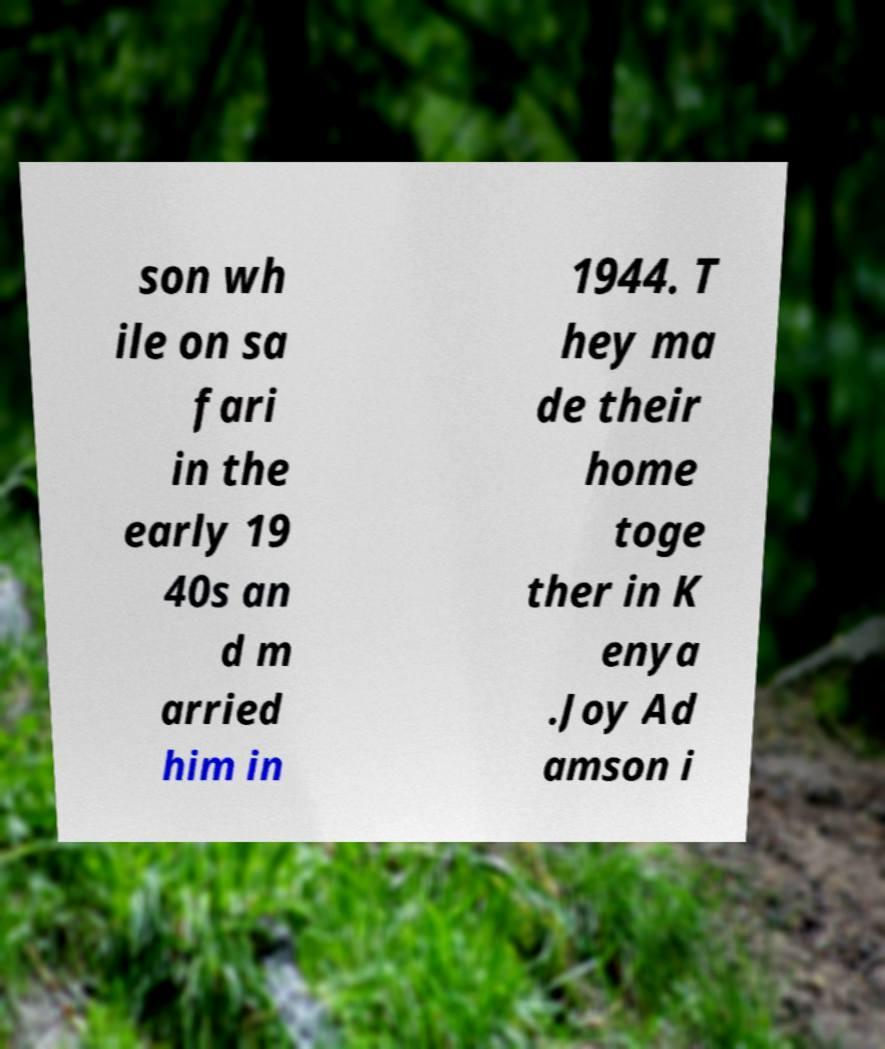Can you read and provide the text displayed in the image?This photo seems to have some interesting text. Can you extract and type it out for me? son wh ile on sa fari in the early 19 40s an d m arried him in 1944. T hey ma de their home toge ther in K enya .Joy Ad amson i 